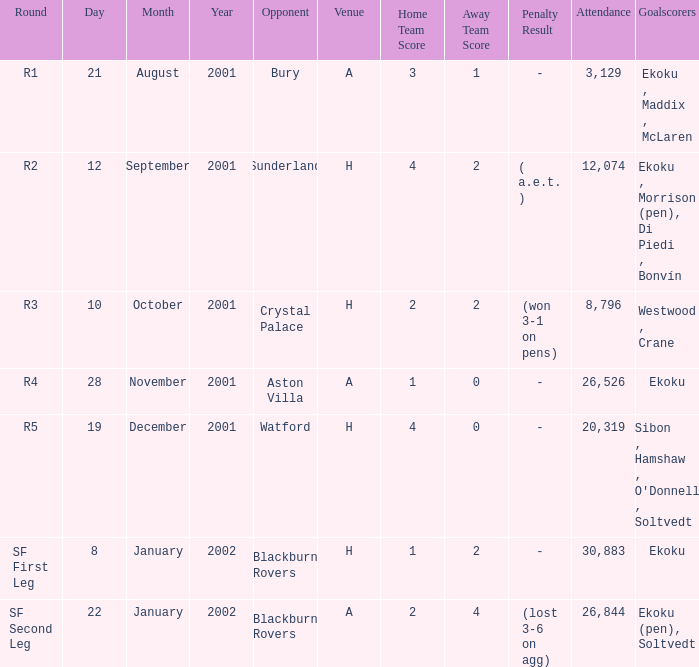Which venue has attendance larger than 26,526, and sf first leg round? H. 